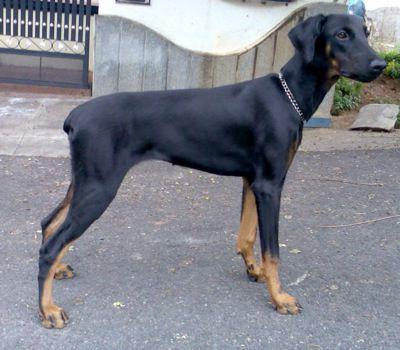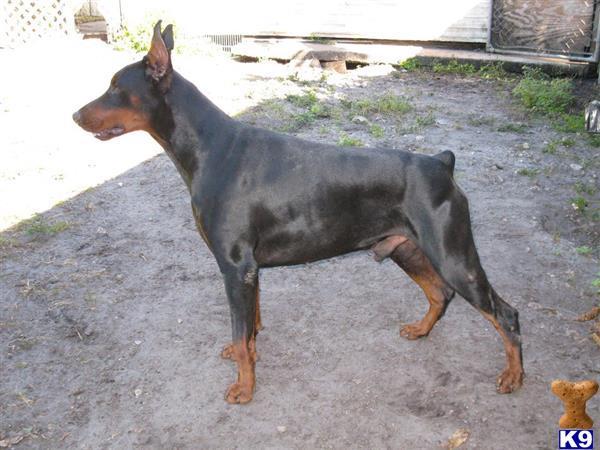The first image is the image on the left, the second image is the image on the right. Examine the images to the left and right. Is the description "Each image features a doberman with erect, upright ears, one of the dobermans depicted has an open mouth, and no doberman has a long tail." accurate? Answer yes or no. No. The first image is the image on the left, the second image is the image on the right. Evaluate the accuracy of this statement regarding the images: "The two dogs' bodies are pointed in opposite directions.". Is it true? Answer yes or no. Yes. 